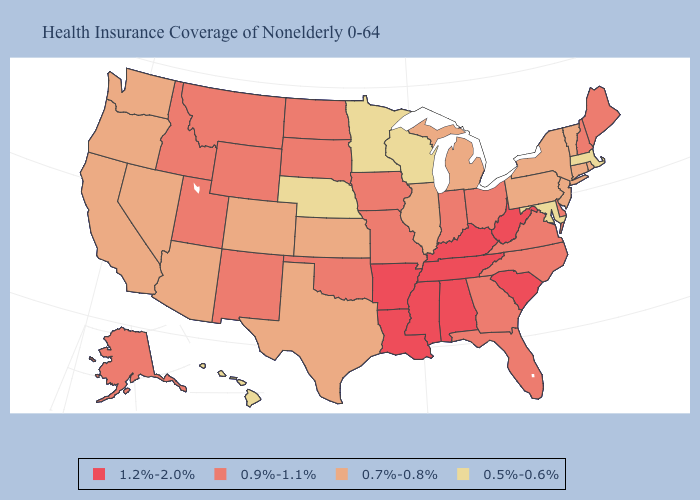Does Massachusetts have a higher value than Idaho?
Write a very short answer. No. What is the highest value in the USA?
Give a very brief answer. 1.2%-2.0%. Name the states that have a value in the range 0.9%-1.1%?
Short answer required. Alaska, Delaware, Florida, Georgia, Idaho, Indiana, Iowa, Maine, Missouri, Montana, New Hampshire, New Mexico, North Carolina, North Dakota, Ohio, Oklahoma, South Dakota, Utah, Virginia, Wyoming. Name the states that have a value in the range 1.2%-2.0%?
Give a very brief answer. Alabama, Arkansas, Kentucky, Louisiana, Mississippi, South Carolina, Tennessee, West Virginia. Which states have the lowest value in the South?
Keep it brief. Maryland. Among the states that border New York , does Massachusetts have the lowest value?
Answer briefly. Yes. What is the value of Pennsylvania?
Answer briefly. 0.7%-0.8%. Among the states that border Virginia , does Kentucky have the lowest value?
Be succinct. No. Name the states that have a value in the range 1.2%-2.0%?
Quick response, please. Alabama, Arkansas, Kentucky, Louisiana, Mississippi, South Carolina, Tennessee, West Virginia. What is the value of Nebraska?
Answer briefly. 0.5%-0.6%. Which states hav the highest value in the Northeast?
Quick response, please. Maine, New Hampshire. What is the value of Indiana?
Quick response, please. 0.9%-1.1%. What is the highest value in the MidWest ?
Keep it brief. 0.9%-1.1%. Name the states that have a value in the range 0.7%-0.8%?
Write a very short answer. Arizona, California, Colorado, Connecticut, Illinois, Kansas, Michigan, Nevada, New Jersey, New York, Oregon, Pennsylvania, Rhode Island, Texas, Vermont, Washington. Name the states that have a value in the range 0.9%-1.1%?
Give a very brief answer. Alaska, Delaware, Florida, Georgia, Idaho, Indiana, Iowa, Maine, Missouri, Montana, New Hampshire, New Mexico, North Carolina, North Dakota, Ohio, Oklahoma, South Dakota, Utah, Virginia, Wyoming. 